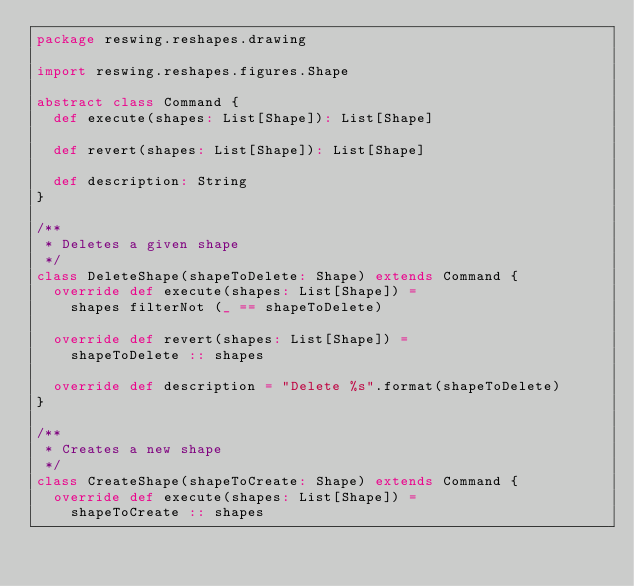Convert code to text. <code><loc_0><loc_0><loc_500><loc_500><_Scala_>package reswing.reshapes.drawing

import reswing.reshapes.figures.Shape

abstract class Command {
  def execute(shapes: List[Shape]): List[Shape]

  def revert(shapes: List[Shape]): List[Shape]

  def description: String
}

/**
 * Deletes a given shape
 */
class DeleteShape(shapeToDelete: Shape) extends Command {
  override def execute(shapes: List[Shape]) =
    shapes filterNot (_ == shapeToDelete)

  override def revert(shapes: List[Shape]) =
    shapeToDelete :: shapes

  override def description = "Delete %s".format(shapeToDelete)
}

/**
 * Creates a new shape
 */
class CreateShape(shapeToCreate: Shape) extends Command {
  override def execute(shapes: List[Shape]) =
    shapeToCreate :: shapes
</code> 